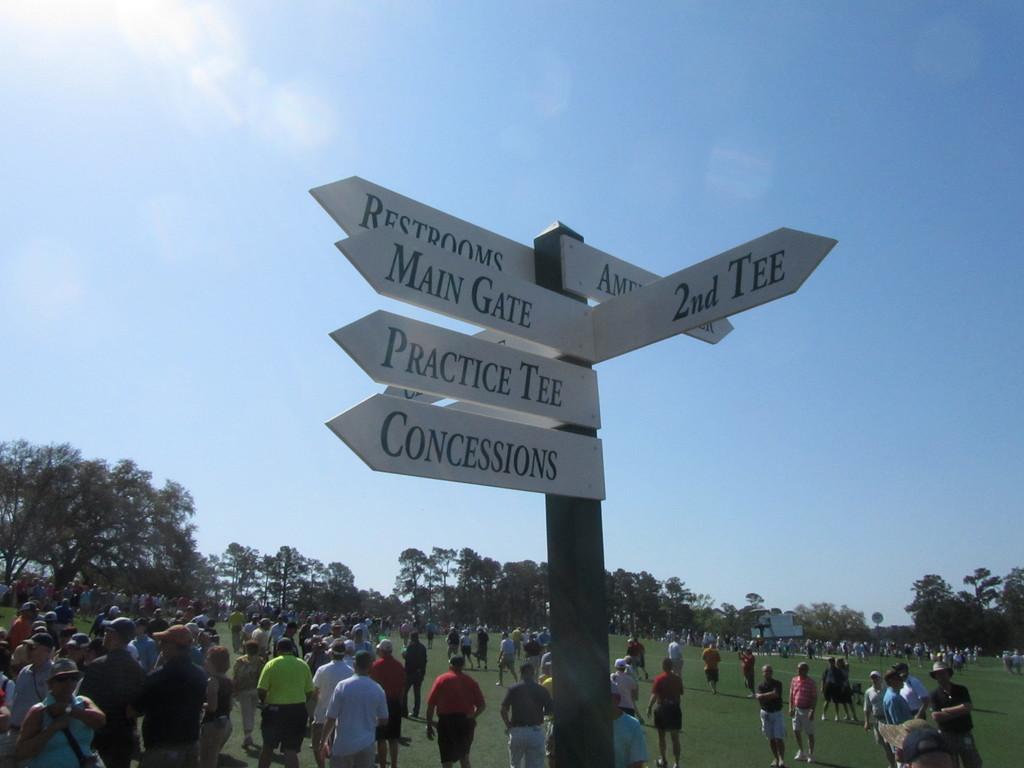How would you summarize this image in a sentence or two? In this image I can see few boards attached to the pole and I can see group of people standing, few trees in green color and the sky is in blue and white color. 